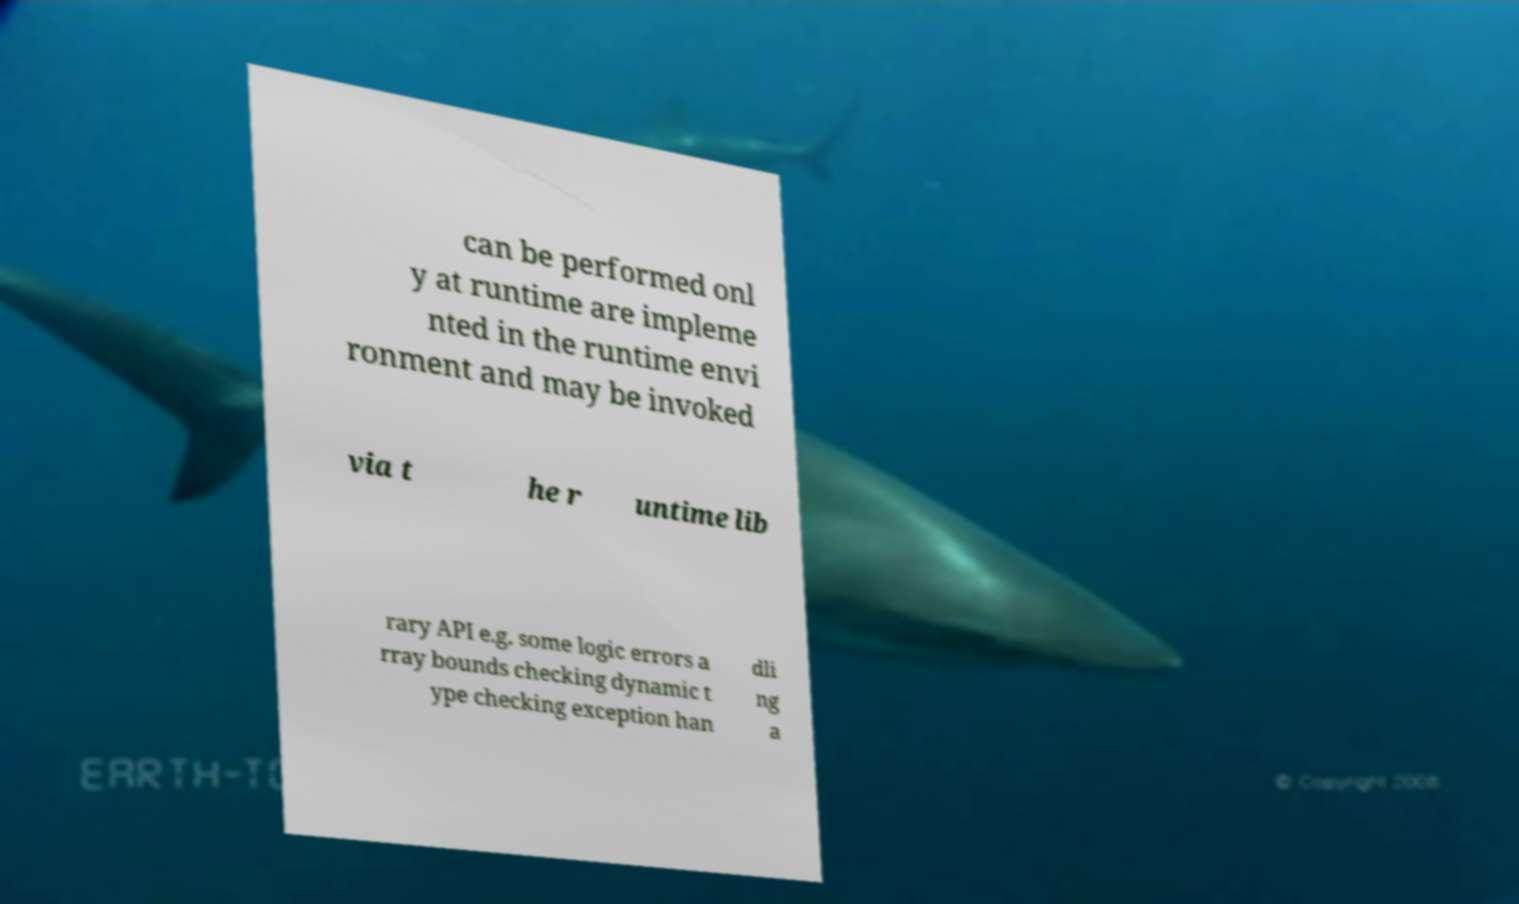For documentation purposes, I need the text within this image transcribed. Could you provide that? can be performed onl y at runtime are impleme nted in the runtime envi ronment and may be invoked via t he r untime lib rary API e.g. some logic errors a rray bounds checking dynamic t ype checking exception han dli ng a 